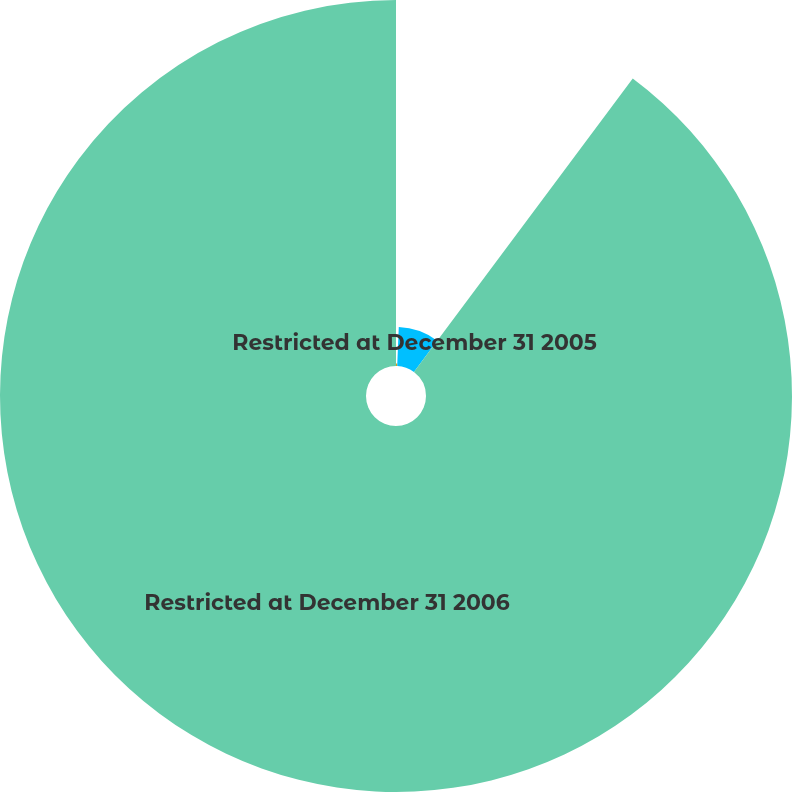Convert chart. <chart><loc_0><loc_0><loc_500><loc_500><pie_chart><fcel>Restricted at December 31 2004<fcel>Restricted at December 31 2005<fcel>Restricted at December 31 2006<nl><fcel>0.64%<fcel>9.56%<fcel>89.81%<nl></chart> 